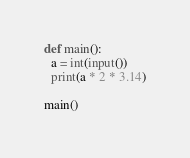Convert code to text. <code><loc_0><loc_0><loc_500><loc_500><_Python_>def main():
  a = int(input())
  print(a * 2 * 3.14)

main()</code> 